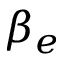Convert formula to latex. <formula><loc_0><loc_0><loc_500><loc_500>\beta _ { e }</formula> 